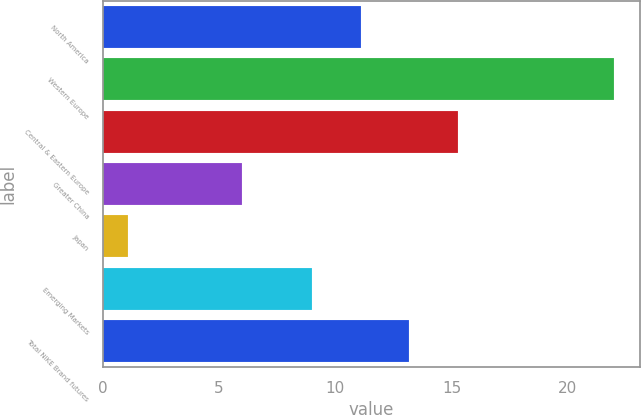Convert chart to OTSL. <chart><loc_0><loc_0><loc_500><loc_500><bar_chart><fcel>North America<fcel>Western Europe<fcel>Central & Eastern Europe<fcel>Greater China<fcel>Japan<fcel>Emerging Markets<fcel>Total NIKE Brand futures<nl><fcel>11.09<fcel>22<fcel>15.27<fcel>6<fcel>1.09<fcel>9<fcel>13.18<nl></chart> 